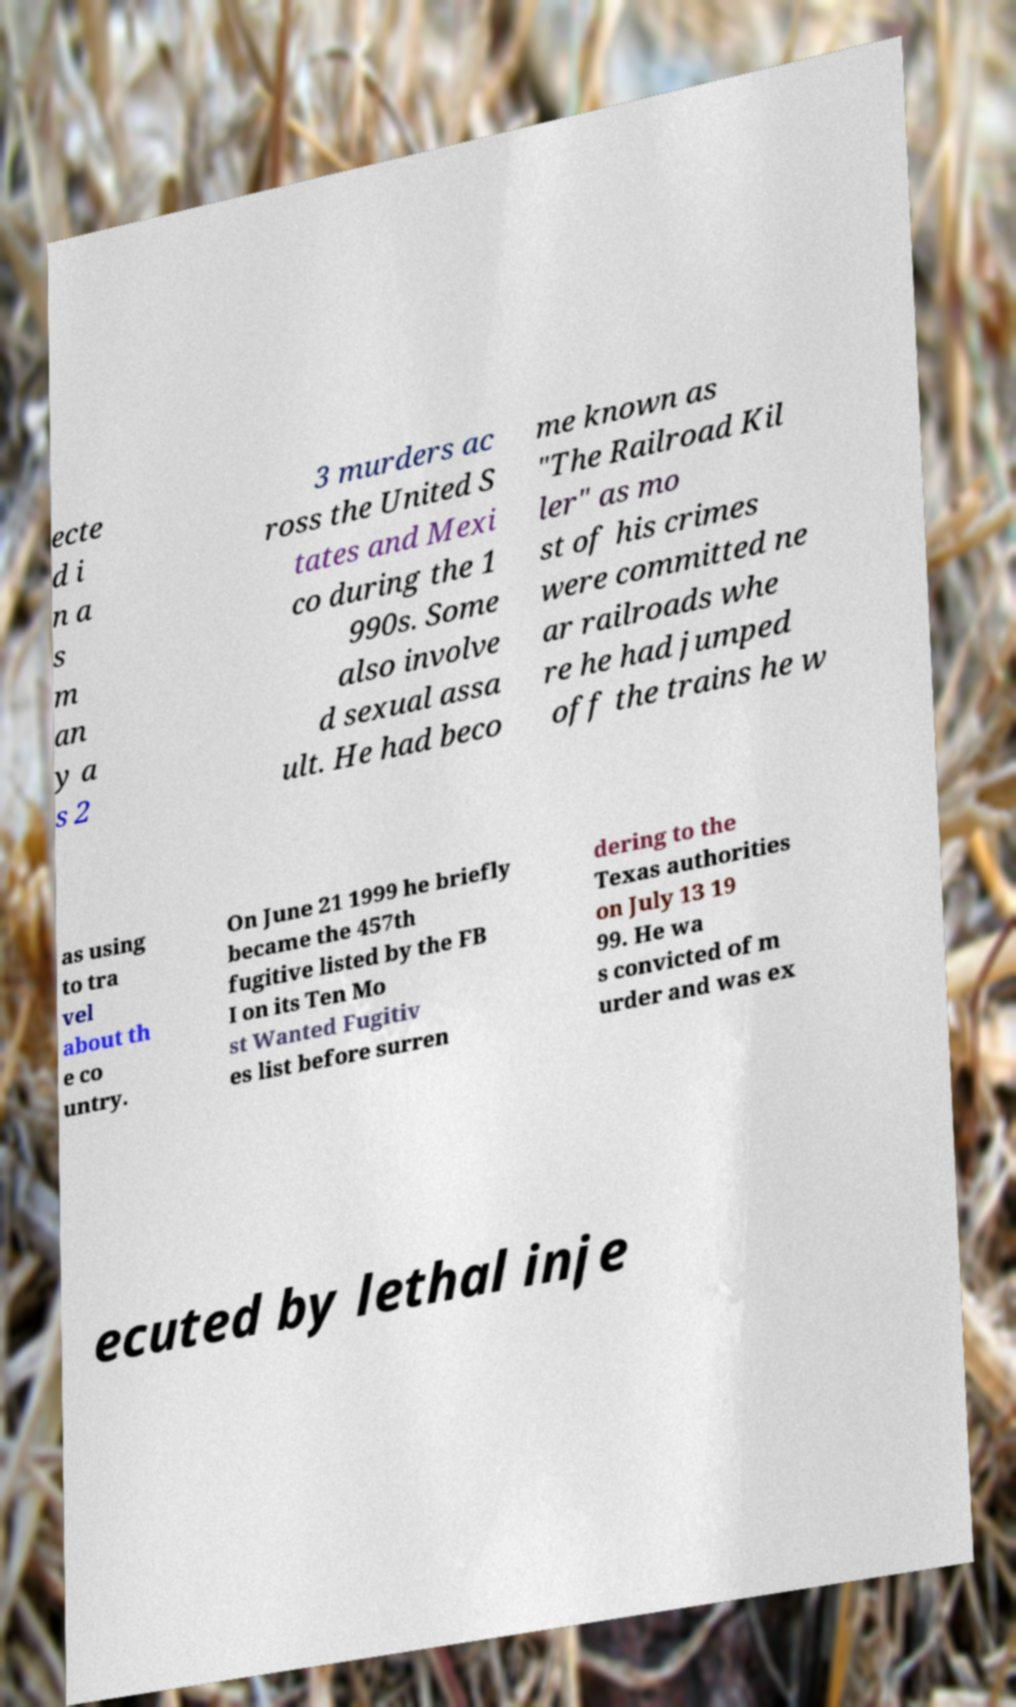Please identify and transcribe the text found in this image. ecte d i n a s m an y a s 2 3 murders ac ross the United S tates and Mexi co during the 1 990s. Some also involve d sexual assa ult. He had beco me known as "The Railroad Kil ler" as mo st of his crimes were committed ne ar railroads whe re he had jumped off the trains he w as using to tra vel about th e co untry. On June 21 1999 he briefly became the 457th fugitive listed by the FB I on its Ten Mo st Wanted Fugitiv es list before surren dering to the Texas authorities on July 13 19 99. He wa s convicted of m urder and was ex ecuted by lethal inje 